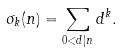Convert formula to latex. <formula><loc_0><loc_0><loc_500><loc_500>\sigma _ { k } ( n ) = \sum _ { 0 < d | n } d ^ { k } .</formula> 